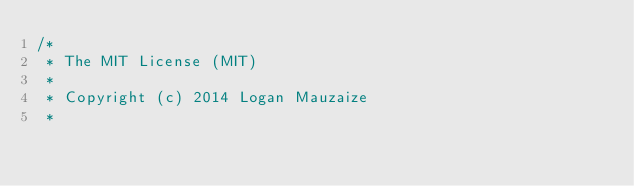<code> <loc_0><loc_0><loc_500><loc_500><_Ceylon_>/*
 * The MIT License (MIT)
 * 
 * Copyright (c) 2014 Logan Mauzaize
 * </code> 